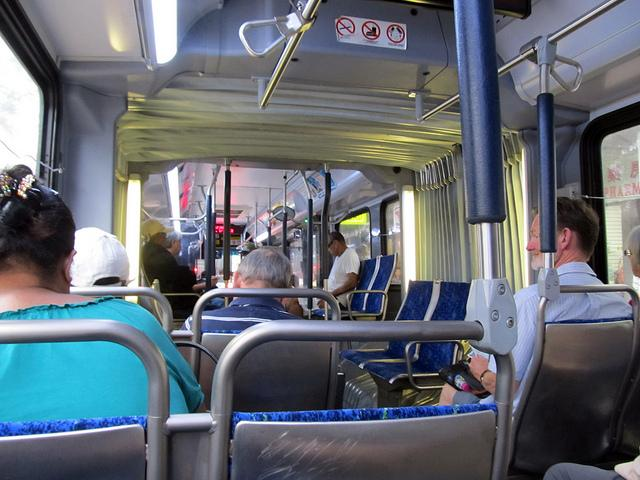What is explicitly forbidden on the bus? smoking 